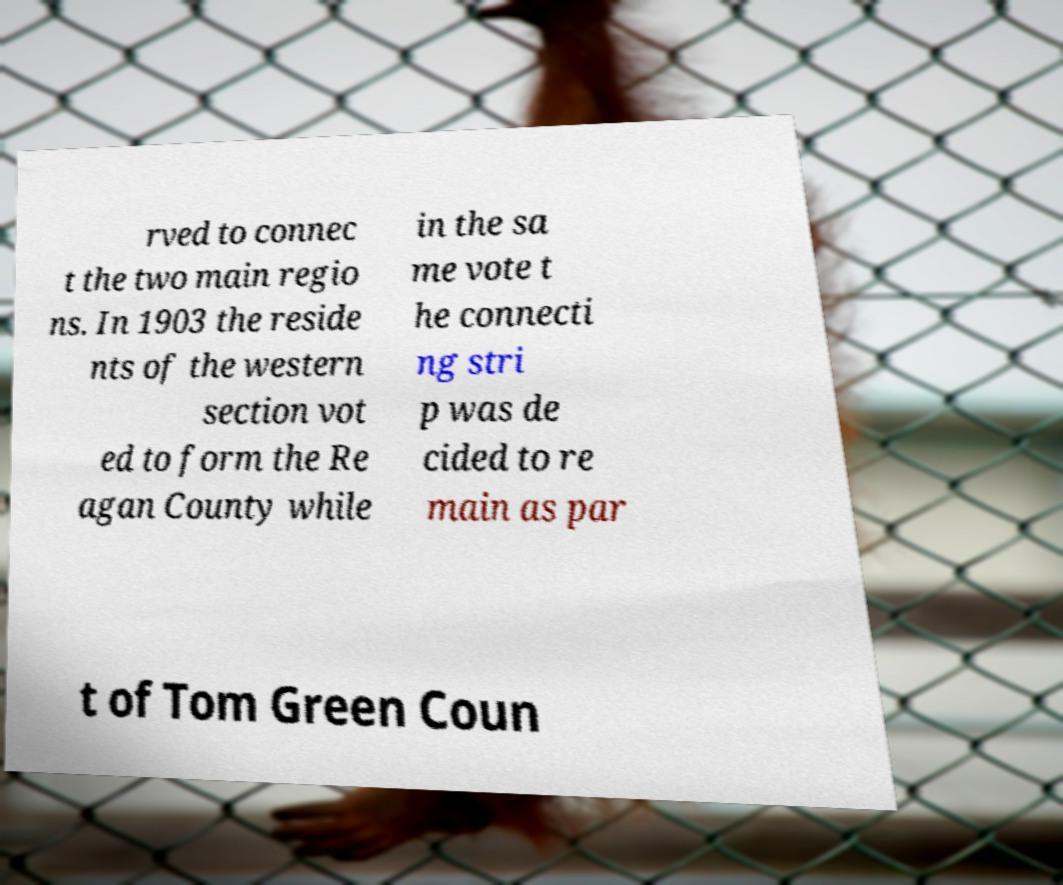What messages or text are displayed in this image? I need them in a readable, typed format. rved to connec t the two main regio ns. In 1903 the reside nts of the western section vot ed to form the Re agan County while in the sa me vote t he connecti ng stri p was de cided to re main as par t of Tom Green Coun 